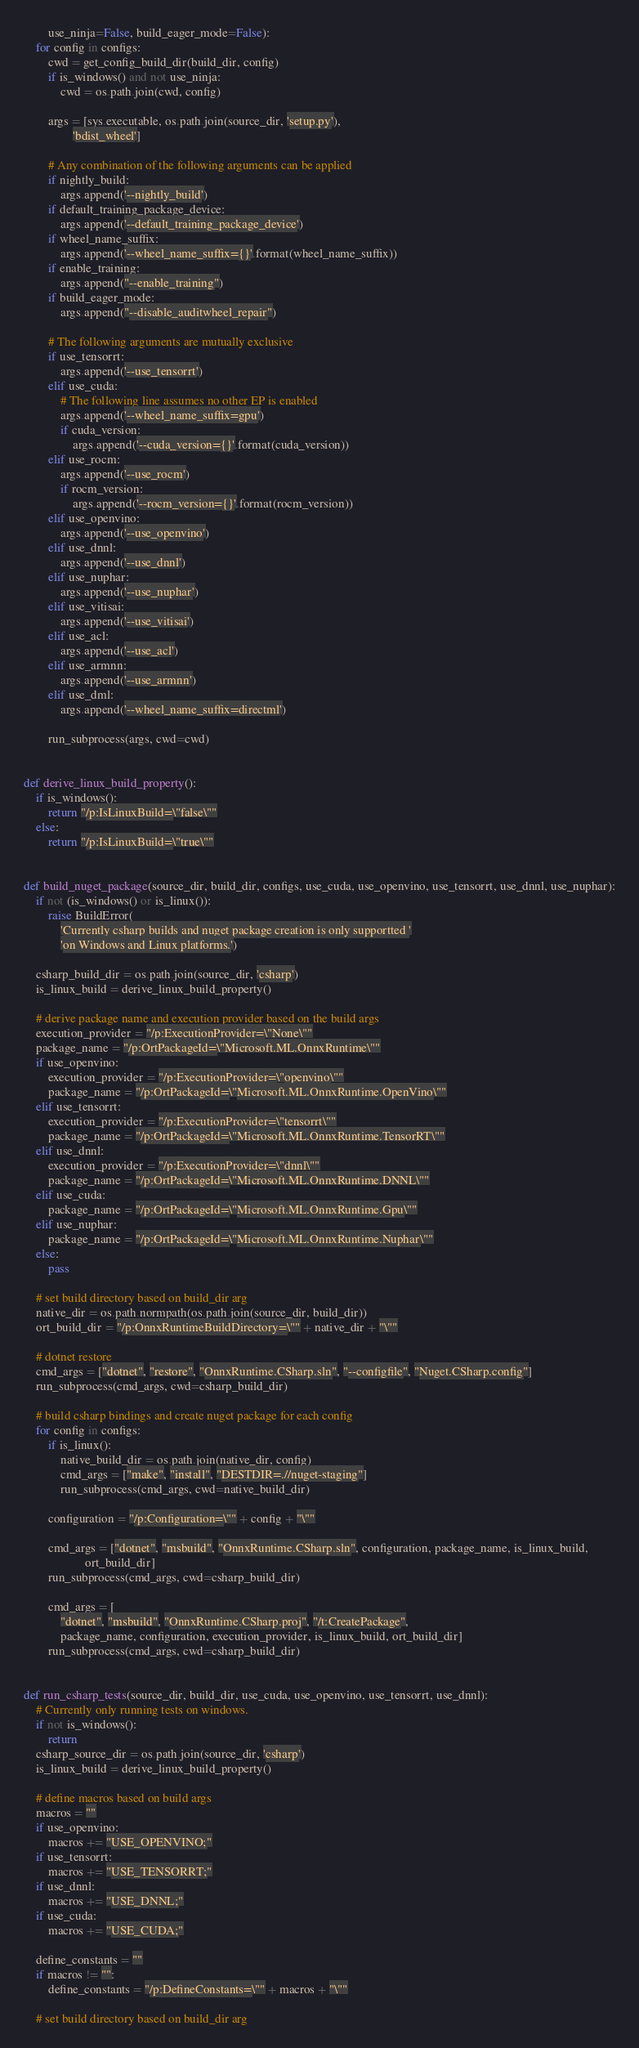<code> <loc_0><loc_0><loc_500><loc_500><_Python_>        use_ninja=False, build_eager_mode=False):
    for config in configs:
        cwd = get_config_build_dir(build_dir, config)
        if is_windows() and not use_ninja:
            cwd = os.path.join(cwd, config)

        args = [sys.executable, os.path.join(source_dir, 'setup.py'),
                'bdist_wheel']

        # Any combination of the following arguments can be applied
        if nightly_build:
            args.append('--nightly_build')
        if default_training_package_device:
            args.append('--default_training_package_device')
        if wheel_name_suffix:
            args.append('--wheel_name_suffix={}'.format(wheel_name_suffix))
        if enable_training:
            args.append("--enable_training")
        if build_eager_mode:
            args.append("--disable_auditwheel_repair")

        # The following arguments are mutually exclusive
        if use_tensorrt:
            args.append('--use_tensorrt')
        elif use_cuda:
            # The following line assumes no other EP is enabled
            args.append('--wheel_name_suffix=gpu')
            if cuda_version:
                args.append('--cuda_version={}'.format(cuda_version))
        elif use_rocm:
            args.append('--use_rocm')
            if rocm_version:
                args.append('--rocm_version={}'.format(rocm_version))
        elif use_openvino:
            args.append('--use_openvino')
        elif use_dnnl:
            args.append('--use_dnnl')
        elif use_nuphar:
            args.append('--use_nuphar')
        elif use_vitisai:
            args.append('--use_vitisai')
        elif use_acl:
            args.append('--use_acl')
        elif use_armnn:
            args.append('--use_armnn')
        elif use_dml:
            args.append('--wheel_name_suffix=directml')

        run_subprocess(args, cwd=cwd)


def derive_linux_build_property():
    if is_windows():
        return "/p:IsLinuxBuild=\"false\""
    else:
        return "/p:IsLinuxBuild=\"true\""


def build_nuget_package(source_dir, build_dir, configs, use_cuda, use_openvino, use_tensorrt, use_dnnl, use_nuphar):
    if not (is_windows() or is_linux()):
        raise BuildError(
            'Currently csharp builds and nuget package creation is only supportted '
            'on Windows and Linux platforms.')

    csharp_build_dir = os.path.join(source_dir, 'csharp')
    is_linux_build = derive_linux_build_property()

    # derive package name and execution provider based on the build args
    execution_provider = "/p:ExecutionProvider=\"None\""
    package_name = "/p:OrtPackageId=\"Microsoft.ML.OnnxRuntime\""
    if use_openvino:
        execution_provider = "/p:ExecutionProvider=\"openvino\""
        package_name = "/p:OrtPackageId=\"Microsoft.ML.OnnxRuntime.OpenVino\""
    elif use_tensorrt:
        execution_provider = "/p:ExecutionProvider=\"tensorrt\""
        package_name = "/p:OrtPackageId=\"Microsoft.ML.OnnxRuntime.TensorRT\""
    elif use_dnnl:
        execution_provider = "/p:ExecutionProvider=\"dnnl\""
        package_name = "/p:OrtPackageId=\"Microsoft.ML.OnnxRuntime.DNNL\""
    elif use_cuda:
        package_name = "/p:OrtPackageId=\"Microsoft.ML.OnnxRuntime.Gpu\""
    elif use_nuphar:
        package_name = "/p:OrtPackageId=\"Microsoft.ML.OnnxRuntime.Nuphar\""
    else:
        pass

    # set build directory based on build_dir arg
    native_dir = os.path.normpath(os.path.join(source_dir, build_dir))
    ort_build_dir = "/p:OnnxRuntimeBuildDirectory=\"" + native_dir + "\""

    # dotnet restore
    cmd_args = ["dotnet", "restore", "OnnxRuntime.CSharp.sln", "--configfile", "Nuget.CSharp.config"]
    run_subprocess(cmd_args, cwd=csharp_build_dir)

    # build csharp bindings and create nuget package for each config
    for config in configs:
        if is_linux():
            native_build_dir = os.path.join(native_dir, config)
            cmd_args = ["make", "install", "DESTDIR=.//nuget-staging"]
            run_subprocess(cmd_args, cwd=native_build_dir)

        configuration = "/p:Configuration=\"" + config + "\""

        cmd_args = ["dotnet", "msbuild", "OnnxRuntime.CSharp.sln", configuration, package_name, is_linux_build,
                    ort_build_dir]
        run_subprocess(cmd_args, cwd=csharp_build_dir)

        cmd_args = [
            "dotnet", "msbuild", "OnnxRuntime.CSharp.proj", "/t:CreatePackage",
            package_name, configuration, execution_provider, is_linux_build, ort_build_dir]
        run_subprocess(cmd_args, cwd=csharp_build_dir)


def run_csharp_tests(source_dir, build_dir, use_cuda, use_openvino, use_tensorrt, use_dnnl):
    # Currently only running tests on windows.
    if not is_windows():
        return
    csharp_source_dir = os.path.join(source_dir, 'csharp')
    is_linux_build = derive_linux_build_property()

    # define macros based on build args
    macros = ""
    if use_openvino:
        macros += "USE_OPENVINO;"
    if use_tensorrt:
        macros += "USE_TENSORRT;"
    if use_dnnl:
        macros += "USE_DNNL;"
    if use_cuda:
        macros += "USE_CUDA;"

    define_constants = ""
    if macros != "":
        define_constants = "/p:DefineConstants=\"" + macros + "\""

    # set build directory based on build_dir arg</code> 